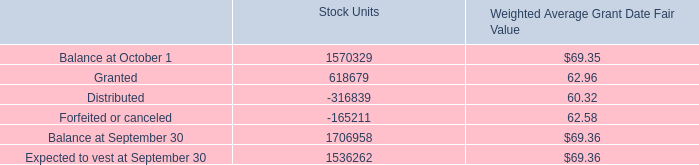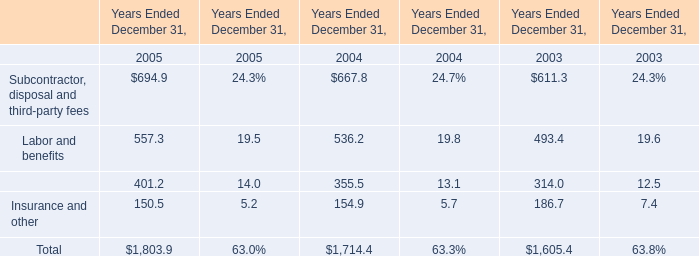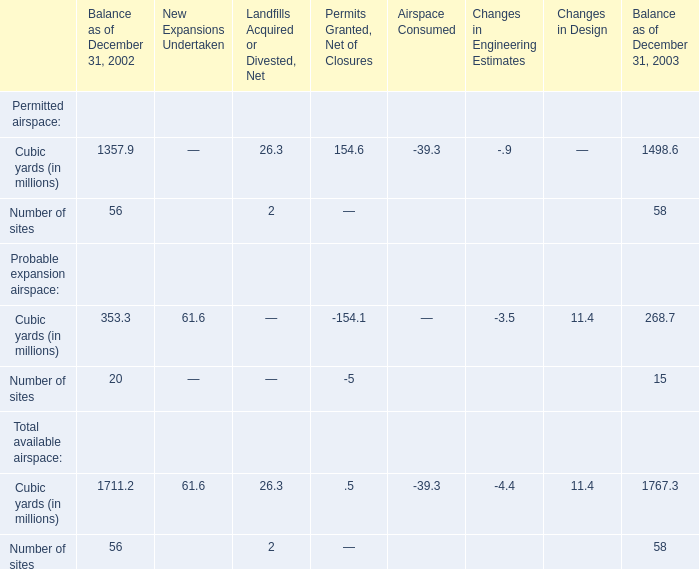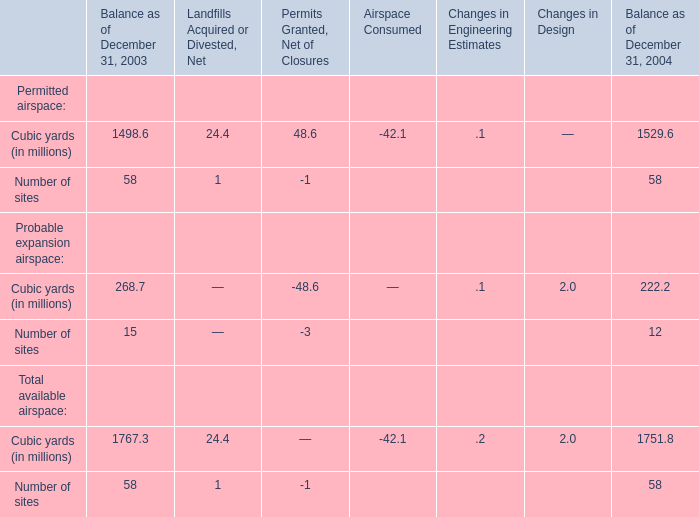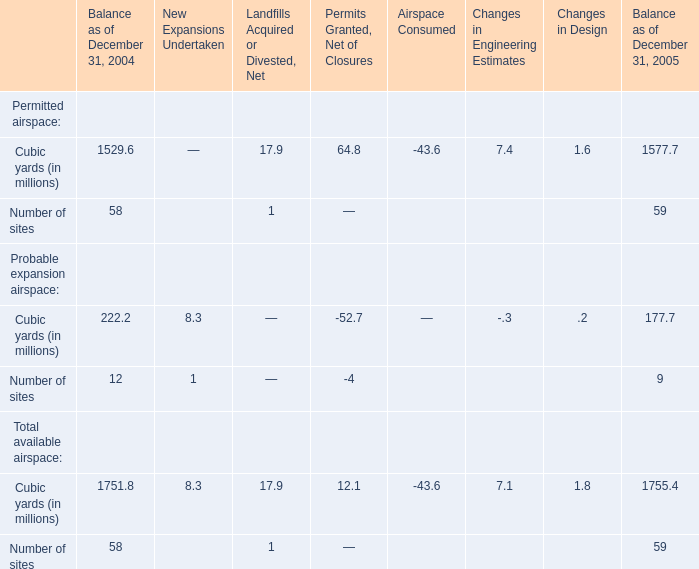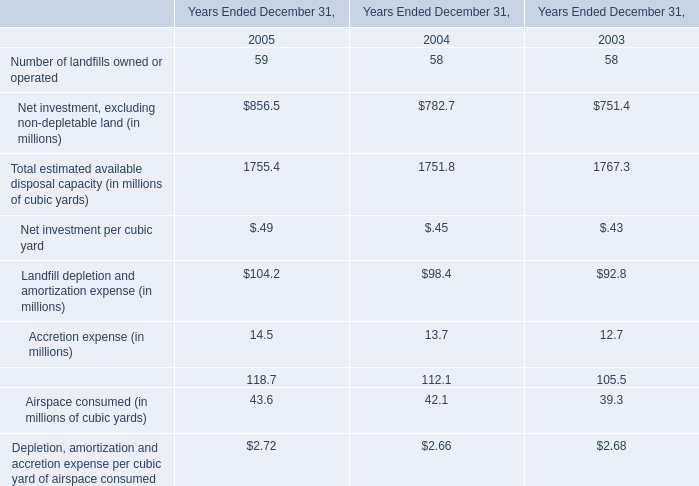What's the total value of all Probable expansion airspace of Cubic yards (in millions) that are smaller than 50 in 2003? (in million) 
Computations: ((-154.1 - 3.5) + 11.4)
Answer: -146.2. 